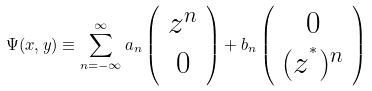Convert formula to latex. <formula><loc_0><loc_0><loc_500><loc_500>\Psi ( x , y ) \equiv \sum _ { n = - \infty } ^ { \infty } a _ { n } \left ( \begin{array} { c } z ^ { n } \\ 0 \end{array} \right ) + b _ { n } \left ( \begin{array} { c } 0 \\ ( z ^ { ^ { * } } ) ^ { n } \end{array} \right )</formula> 